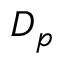Convert formula to latex. <formula><loc_0><loc_0><loc_500><loc_500>D _ { p }</formula> 